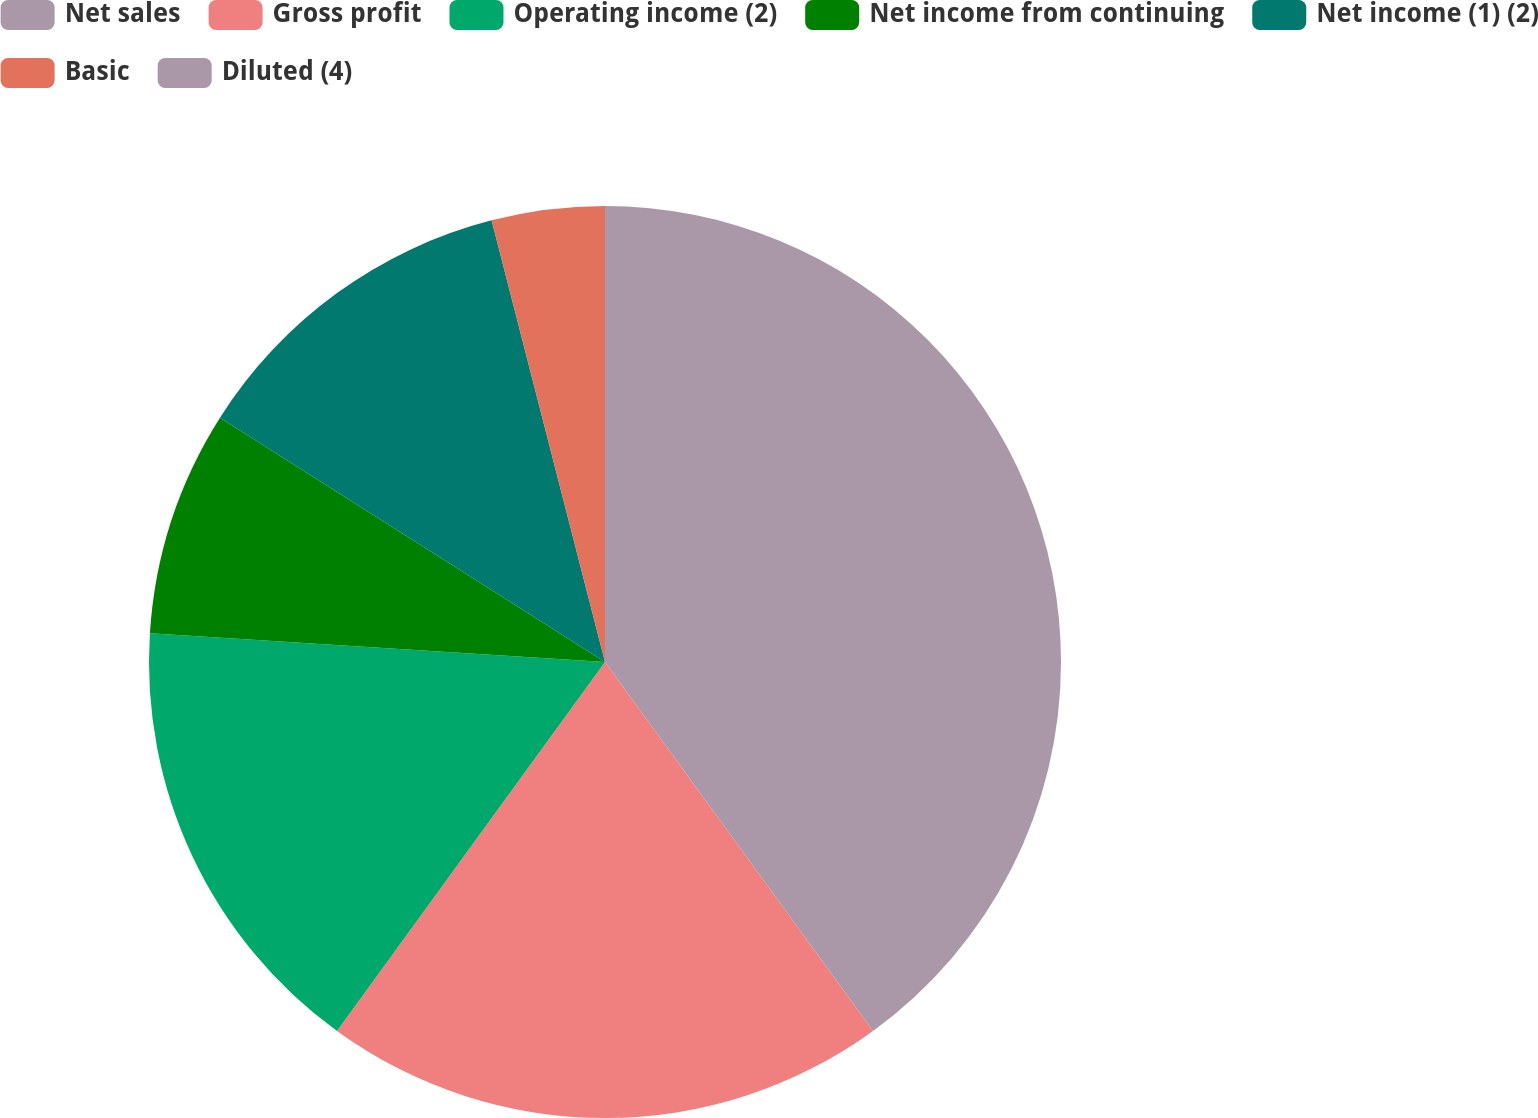Convert chart to OTSL. <chart><loc_0><loc_0><loc_500><loc_500><pie_chart><fcel>Net sales<fcel>Gross profit<fcel>Operating income (2)<fcel>Net income from continuing<fcel>Net income (1) (2)<fcel>Basic<fcel>Diluted (4)<nl><fcel>40.0%<fcel>20.0%<fcel>16.0%<fcel>8.0%<fcel>12.0%<fcel>4.0%<fcel>0.0%<nl></chart> 